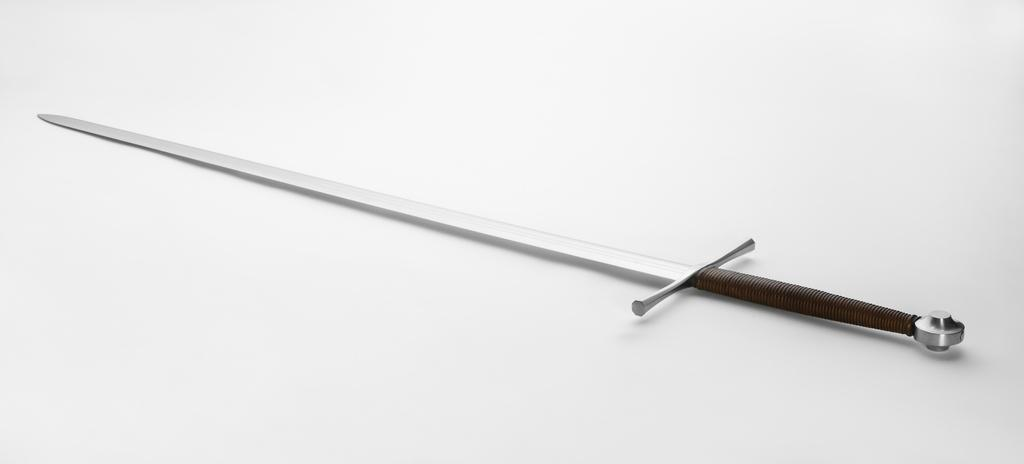What object can be seen in the image? There is a knife in the image. Can you see a snake performing magic tricks with the knife in the image? No, there is no snake or magic tricks present in the image; it only features a knife. 